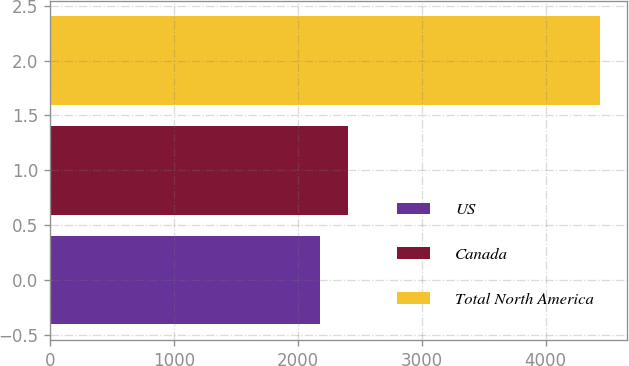Convert chart. <chart><loc_0><loc_0><loc_500><loc_500><bar_chart><fcel>US<fcel>Canada<fcel>Total North America<nl><fcel>2179<fcel>2404.8<fcel>4437<nl></chart> 